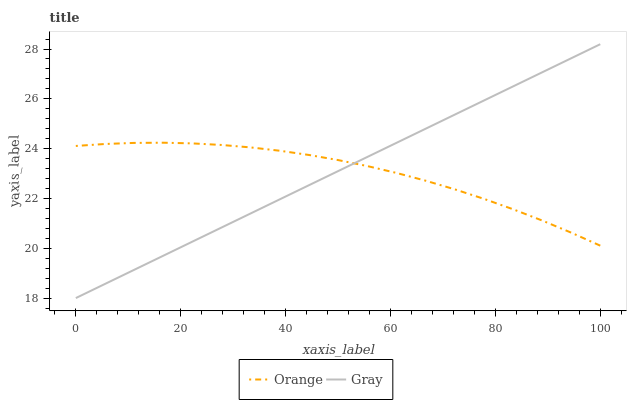Does Orange have the minimum area under the curve?
Answer yes or no. Yes. Does Gray have the maximum area under the curve?
Answer yes or no. Yes. Does Gray have the minimum area under the curve?
Answer yes or no. No. Is Gray the smoothest?
Answer yes or no. Yes. Is Orange the roughest?
Answer yes or no. Yes. Is Gray the roughest?
Answer yes or no. No. Does Gray have the lowest value?
Answer yes or no. Yes. Does Gray have the highest value?
Answer yes or no. Yes. Does Orange intersect Gray?
Answer yes or no. Yes. Is Orange less than Gray?
Answer yes or no. No. Is Orange greater than Gray?
Answer yes or no. No. 